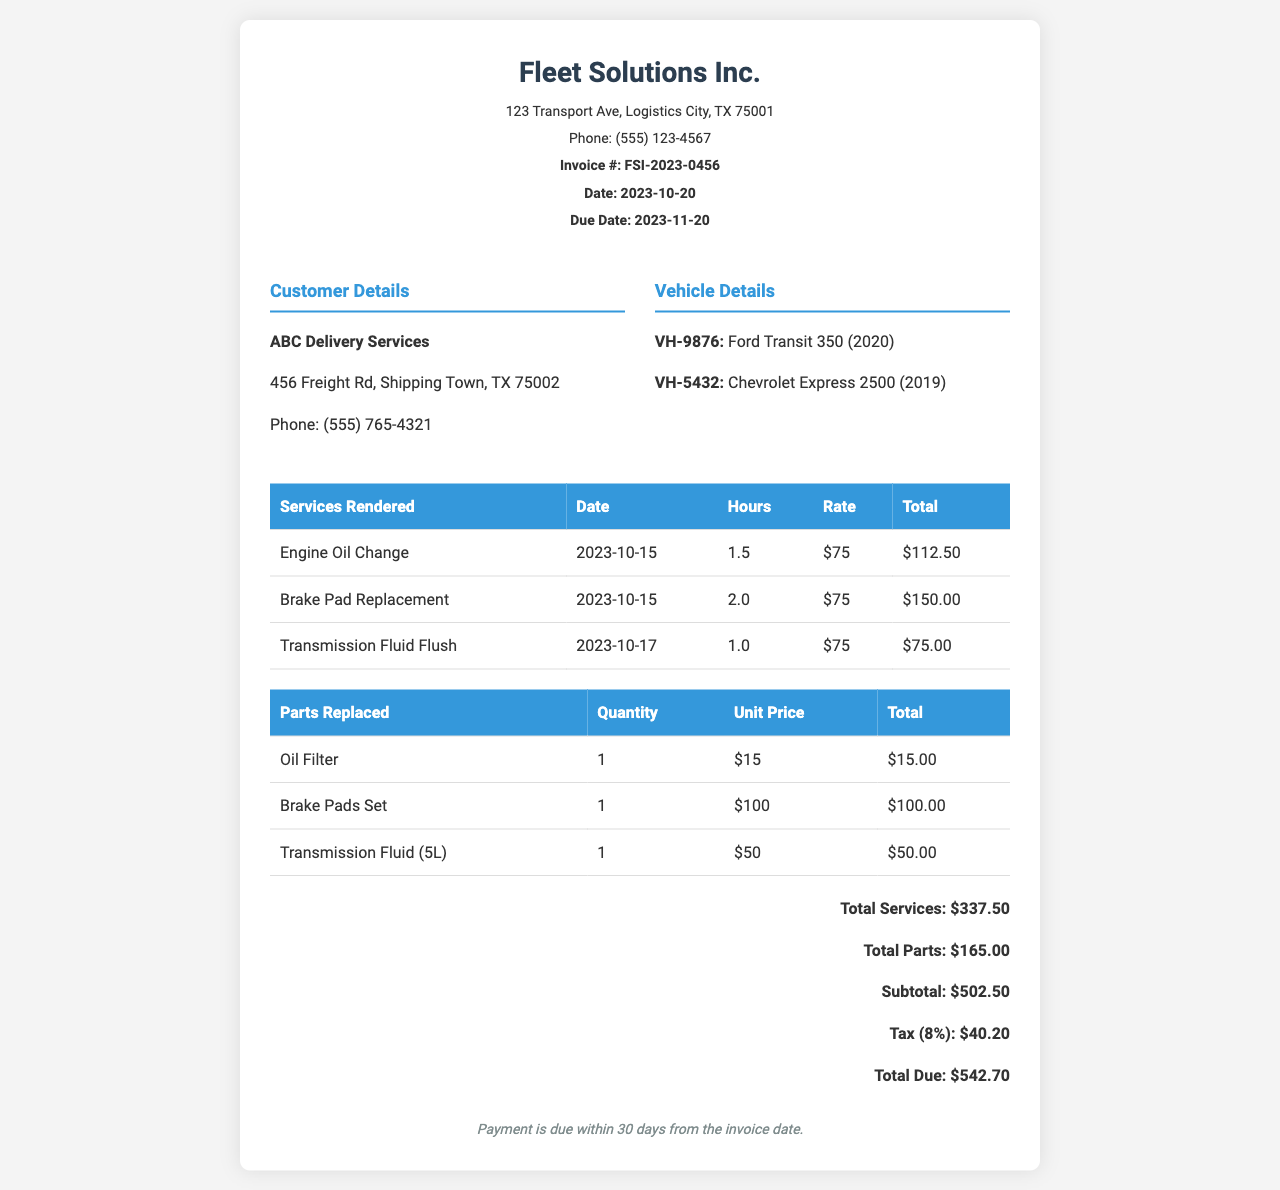What is the invoice number? The invoice number is clearly listed in the header of the document under "Invoice #".
Answer: FSI-2023-0456 What are the customer details? Customer details specify the name and address of the customer.
Answer: ABC Delivery Services, 456 Freight Rd, Shipping Town, TX 75002 What was the total due amount? The total due amount is calculated and presented at the end of the invoice.
Answer: $542.70 How many hours were billed for the Brake Pad Replacement service? The document lists the hours worked for each service rendered in the service table.
Answer: 2.0 What is the total cost for parts replaced? The total cost for parts is summarized in the invoice, reflecting the total of all parts.
Answer: $165.00 Which vehicle was serviced on October 15, 2023? The services rendered include dates, specifying actions taken on specific vehicles.
Answer: VH-9876: Ford Transit 350 (2020) What is the tax percentage applied in the invoice? The tax amount is calculated based on the subtotal, which relates to a specific tax rate.
Answer: 8% What service was performed on October 17, 2023? The date in the services rendered table indicates which maintenance actions correspond to that date.
Answer: Transmission Fluid Flush 